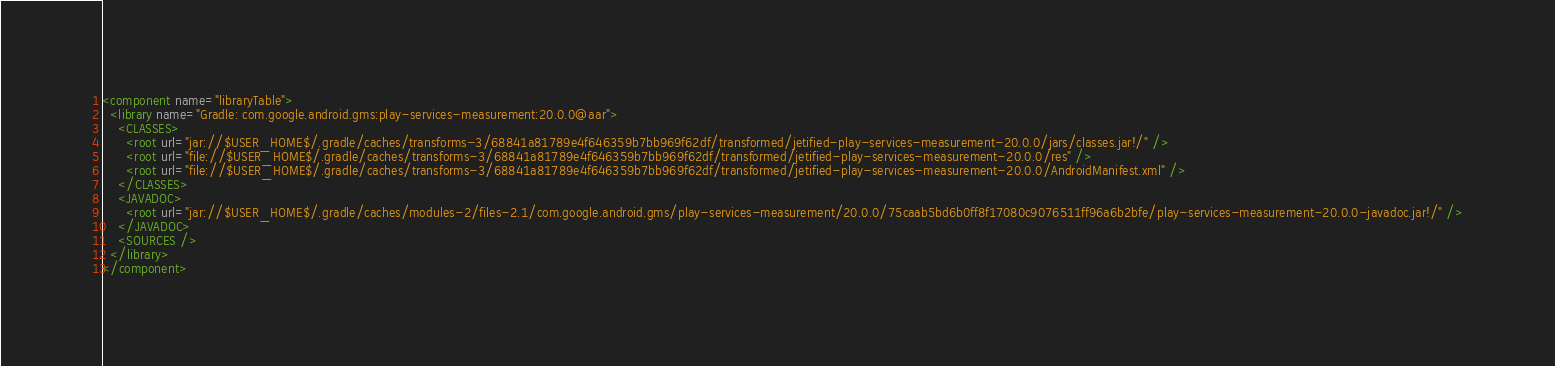Convert code to text. <code><loc_0><loc_0><loc_500><loc_500><_XML_><component name="libraryTable">
  <library name="Gradle: com.google.android.gms:play-services-measurement:20.0.0@aar">
    <CLASSES>
      <root url="jar://$USER_HOME$/.gradle/caches/transforms-3/68841a81789e4f646359b7bb969f62df/transformed/jetified-play-services-measurement-20.0.0/jars/classes.jar!/" />
      <root url="file://$USER_HOME$/.gradle/caches/transforms-3/68841a81789e4f646359b7bb969f62df/transformed/jetified-play-services-measurement-20.0.0/res" />
      <root url="file://$USER_HOME$/.gradle/caches/transforms-3/68841a81789e4f646359b7bb969f62df/transformed/jetified-play-services-measurement-20.0.0/AndroidManifest.xml" />
    </CLASSES>
    <JAVADOC>
      <root url="jar://$USER_HOME$/.gradle/caches/modules-2/files-2.1/com.google.android.gms/play-services-measurement/20.0.0/75caab5bd6b0ff8f17080c9076511ff96a6b2bfe/play-services-measurement-20.0.0-javadoc.jar!/" />
    </JAVADOC>
    <SOURCES />
  </library>
</component></code> 